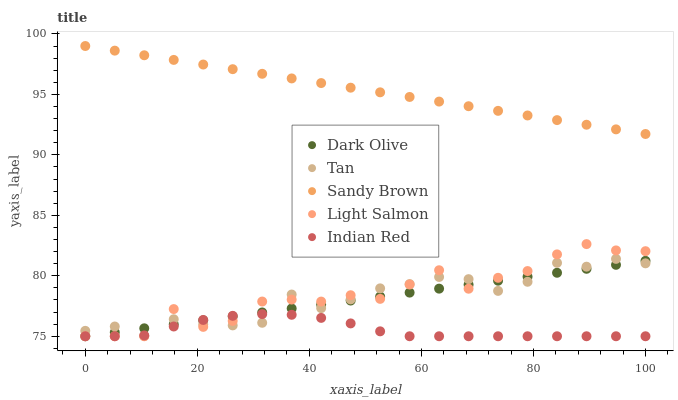Does Indian Red have the minimum area under the curve?
Answer yes or no. Yes. Does Sandy Brown have the maximum area under the curve?
Answer yes or no. Yes. Does Dark Olive have the minimum area under the curve?
Answer yes or no. No. Does Dark Olive have the maximum area under the curve?
Answer yes or no. No. Is Sandy Brown the smoothest?
Answer yes or no. Yes. Is Light Salmon the roughest?
Answer yes or no. Yes. Is Dark Olive the smoothest?
Answer yes or no. No. Is Dark Olive the roughest?
Answer yes or no. No. Does Dark Olive have the lowest value?
Answer yes or no. Yes. Does Sandy Brown have the lowest value?
Answer yes or no. No. Does Sandy Brown have the highest value?
Answer yes or no. Yes. Does Dark Olive have the highest value?
Answer yes or no. No. Is Dark Olive less than Sandy Brown?
Answer yes or no. Yes. Is Sandy Brown greater than Dark Olive?
Answer yes or no. Yes. Does Tan intersect Dark Olive?
Answer yes or no. Yes. Is Tan less than Dark Olive?
Answer yes or no. No. Is Tan greater than Dark Olive?
Answer yes or no. No. Does Dark Olive intersect Sandy Brown?
Answer yes or no. No. 